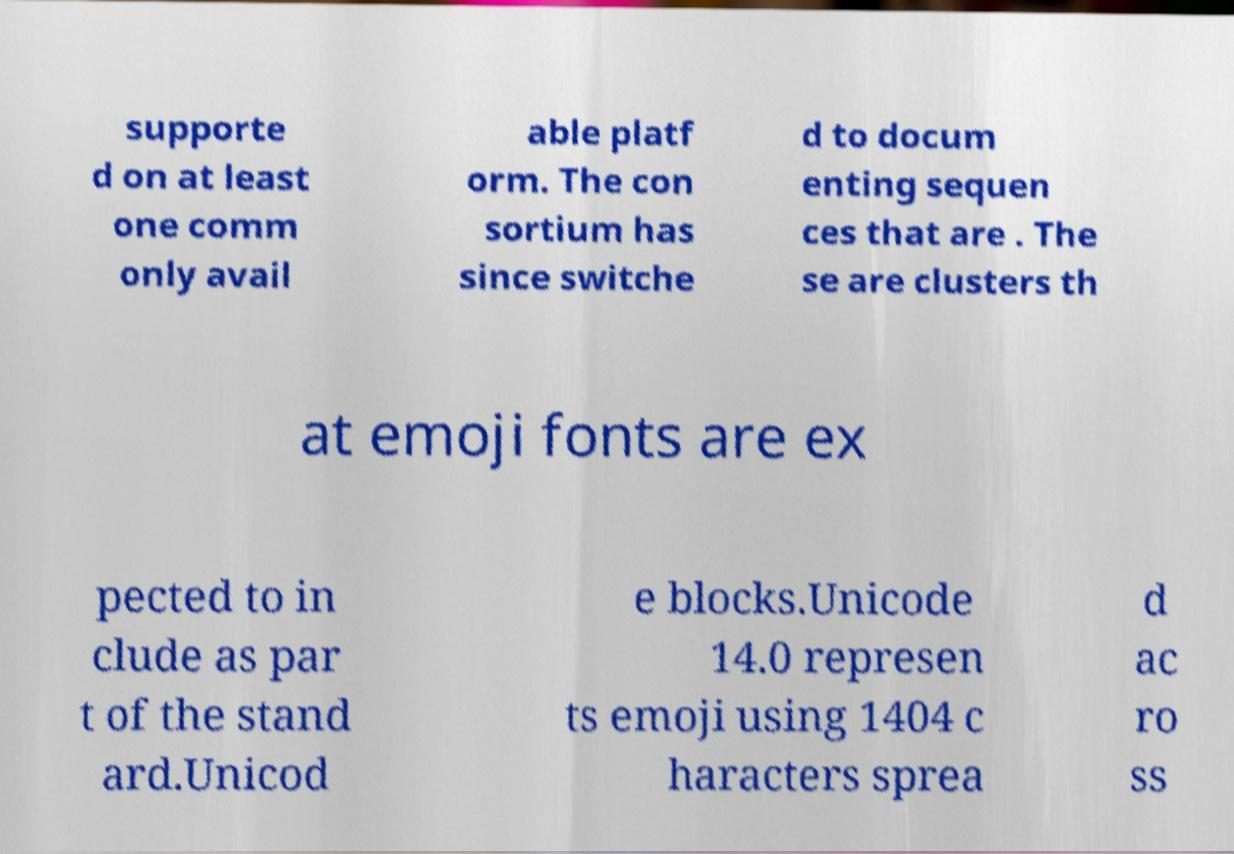For documentation purposes, I need the text within this image transcribed. Could you provide that? supporte d on at least one comm only avail able platf orm. The con sortium has since switche d to docum enting sequen ces that are . The se are clusters th at emoji fonts are ex pected to in clude as par t of the stand ard.Unicod e blocks.Unicode 14.0 represen ts emoji using 1404 c haracters sprea d ac ro ss 